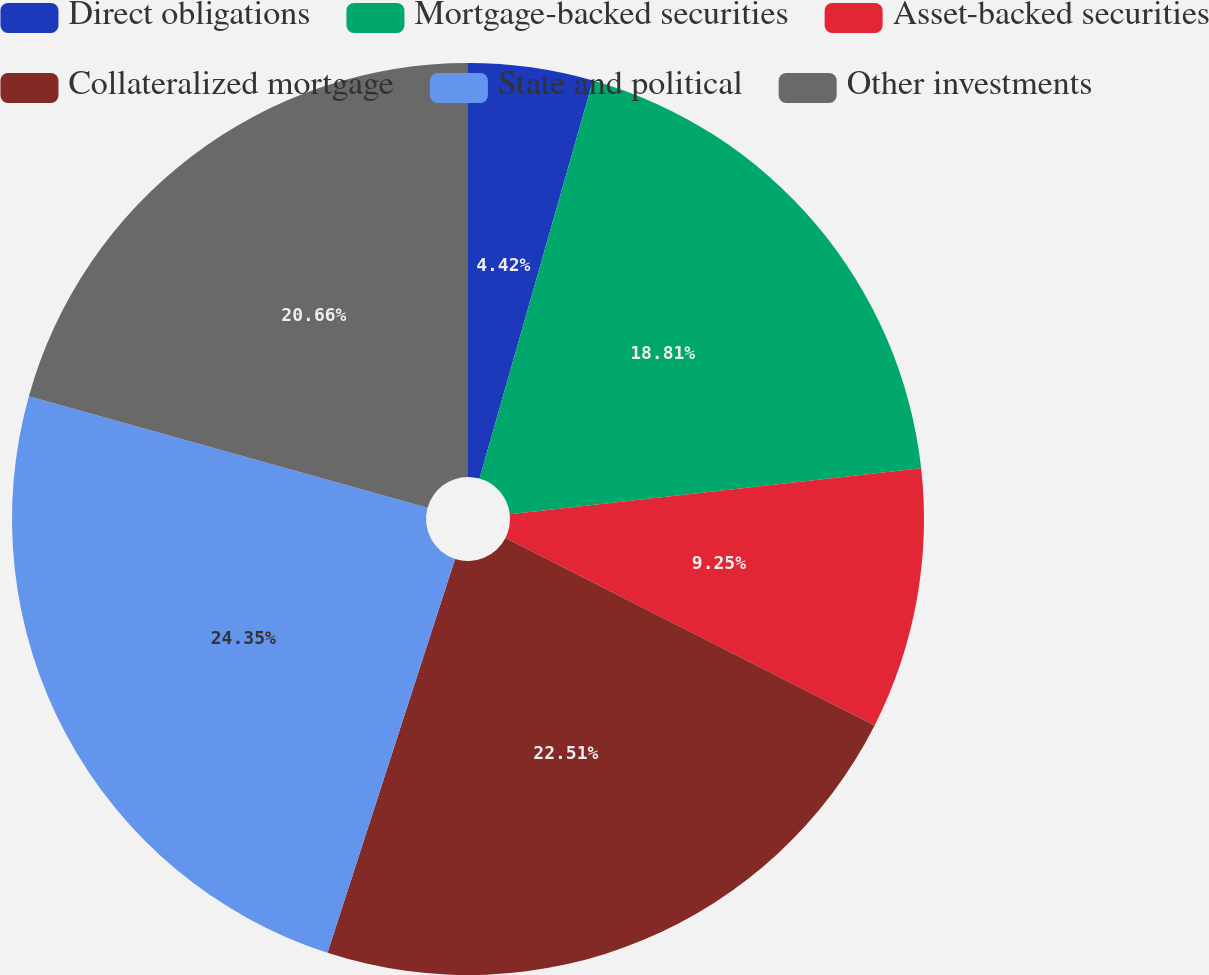Convert chart to OTSL. <chart><loc_0><loc_0><loc_500><loc_500><pie_chart><fcel>Direct obligations<fcel>Mortgage-backed securities<fcel>Asset-backed securities<fcel>Collateralized mortgage<fcel>State and political<fcel>Other investments<nl><fcel>4.42%<fcel>18.81%<fcel>9.25%<fcel>22.51%<fcel>24.36%<fcel>20.66%<nl></chart> 